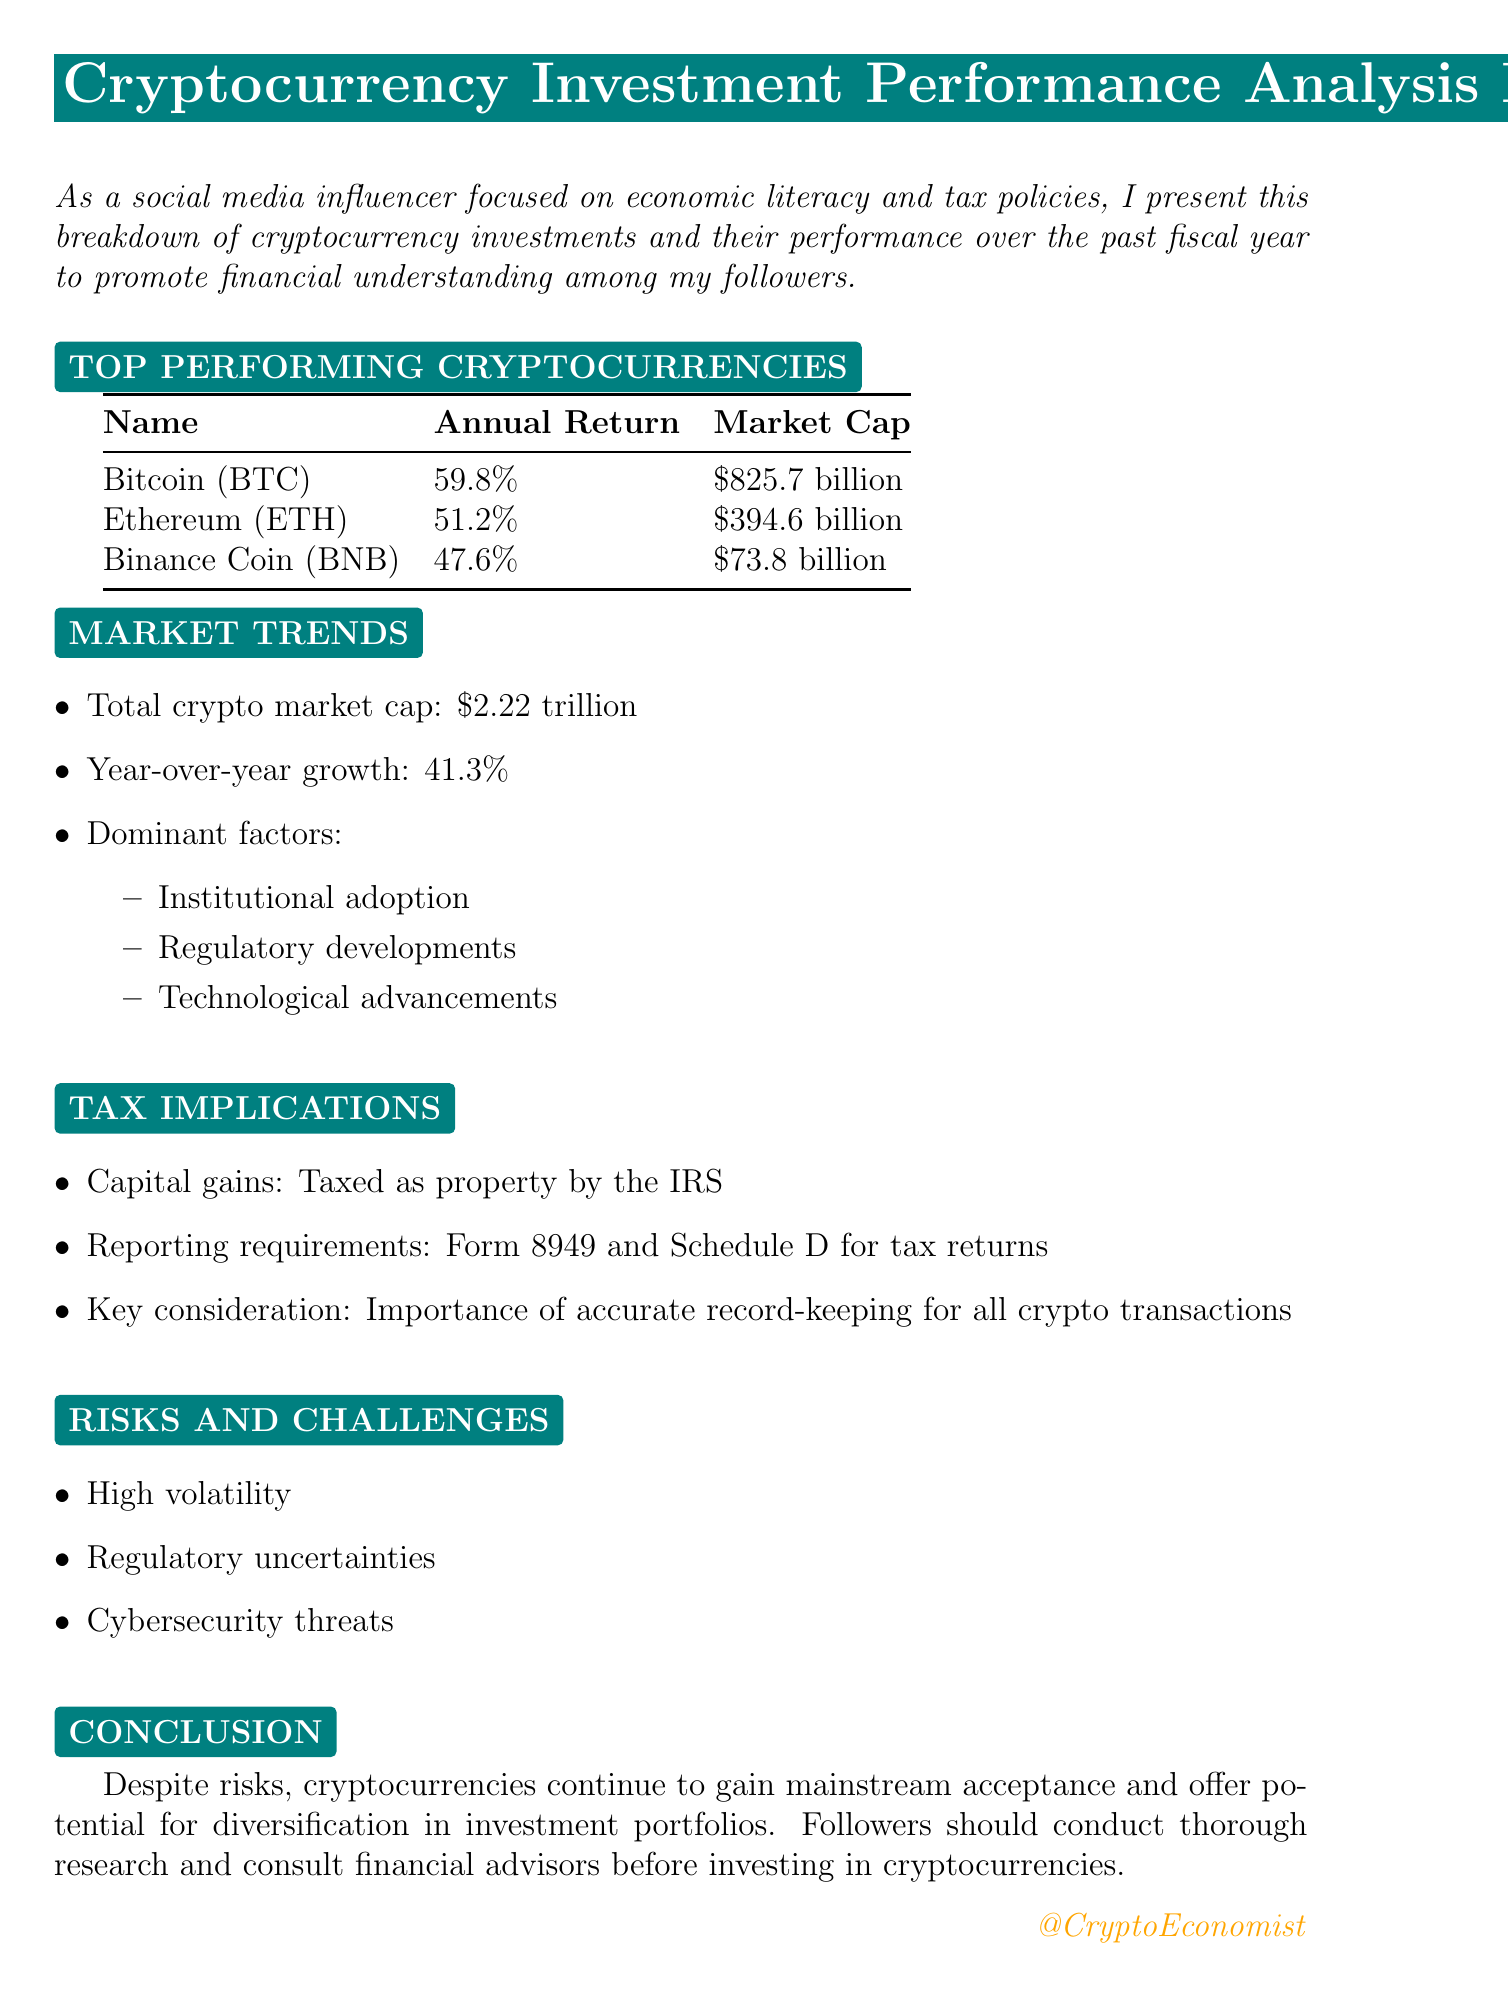What is the title of the report? The title of the report is stated at the beginning of the document.
Answer: Cryptocurrency Investment Performance Analysis FY 2022-2023 What is the annual return of Bitcoin? The document lists Bitcoin's annual return among the top-performing cryptocurrencies.
Answer: 59.8% What is the market cap of Ethereum? The market cap of Ethereum is provided in the section about top-performing cryptocurrencies.
Answer: $394.6 billion What is the total crypto market cap? The total crypto market cap is summarized in the market trends section of the report.
Answer: $2.22 trillion What is the year-over-year growth percentage? The year-over-year growth percentage is included in the market trends section.
Answer: 41.3% What form is required for tax reporting of cryptocurrency gains? The document specifies the reporting requirements for cryptocurrency taxes.
Answer: Form 8949 What is a key consideration for crypto transactions? The document highlights a crucial aspect of managing cryptocurrency transactions concerning taxes.
Answer: Importance of accurate record-keeping What are two challenges mentioned in the report? The document describes risks and challenges associated with cryptocurrency investments.
Answer: High volatility, Regulatory uncertainties What advice is given to followers regarding cryptocurrency investments? The conclusion section includes advice for followers about investing in cryptocurrencies.
Answer: Conduct thorough research and consult financial advisors 